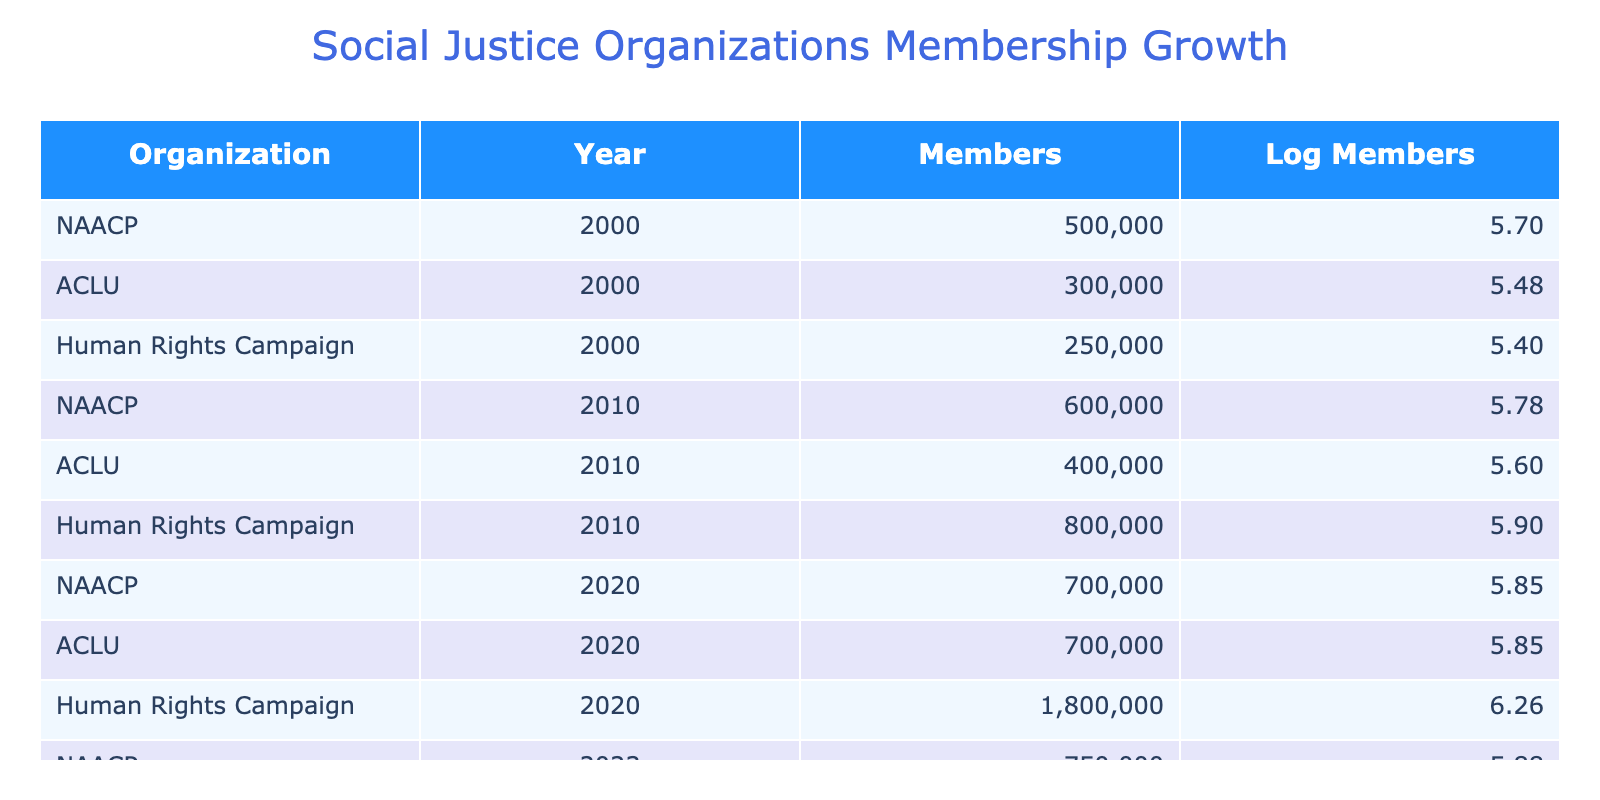What was the membership of the NAACP in 2010? According to the table, the membership of the NAACP in 2010 is specified as 600,000 members.
Answer: 600000 What is the logarithmic value of the membership for the Human Rights Campaign in 2023? The table indicates the Human Rights Campaign had 2,200,000 members in 2023. The logarithmic value is calculated as log10(2200000) which is approximately 6.34.
Answer: 6.34 How many total members were recorded for the ACLU across all years? The total membership for ACLU can be found by summing the members from each year: 300,000 + 400,000 + 700,000 + 720,000 = 2,120,000.
Answer: 2120000 Did the membership of the Human Rights Campaign increase every decade? Observing the table, the membership for the Human Rights Campaign shows 250,000 in 2000, 800,000 in 2010, 1,800,000 in 2020, and 2,200,000 in 2023, indicating consistent growth every decade.
Answer: Yes What was the average membership for the NAACP from 2000 to 2023? The NAACP had 500,000 members in 2000, 600,000 in 2010, 700,000 in 2020, and 750,000 in 2023. Adding these values gives 2,550,000, and dividing by the 4 data points results in an average of 637,500 members.
Answer: 637500 Which organization had the highest membership in 2023? In 2023, the table shows that the Human Rights Campaign had the highest membership of 2,200,000 members compared to NAACP with 750,000 and ACLU with 720,000.
Answer: Human Rights Campaign What was the difference in membership for the ACLU between 2000 and 2020? The ACLU had 300,000 members in 2000 and 700,000 members in 2020. The difference can be calculated as 700,000 - 300,000 = 400,000.
Answer: 400000 What is the sum of the logarithmic values for all organizations in 2020? The logarithmic values for 2020 are as follows: NAACP (700,000) is approximately 5.84, ACLU (700,000) is approximately 5.84, and Human Rights Campaign (1,800,000) is approximately 6.26. Adding these logs gives 5.84 + 5.84 + 6.26 = 17.94.
Answer: 17.94 